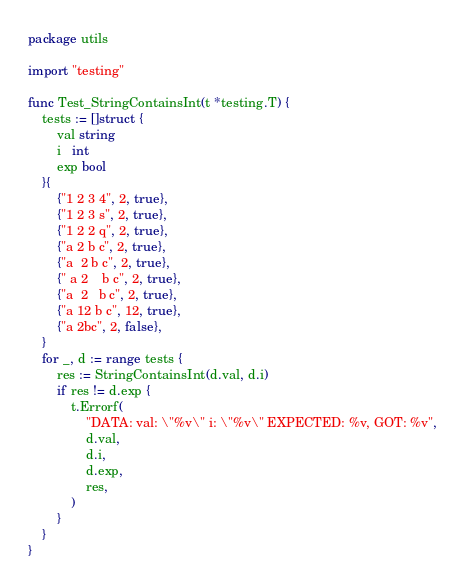Convert code to text. <code><loc_0><loc_0><loc_500><loc_500><_Go_>package utils

import "testing"

func Test_StringContainsInt(t *testing.T) {
	tests := []struct {
		val string
		i   int
		exp bool
	}{
		{"1 2 3 4", 2, true},
		{"1 2 3 s", 2, true},
		{"1 2 2 q", 2, true},
		{"a 2 b c", 2, true},
		{"a 	2 b c", 2, true},
		{" a 2 	 b c", 2, true},
		{"a	2	b c", 2, true},
		{"a 12 b c", 12, true},
		{"a 2bc", 2, false},
	}
	for _, d := range tests {
		res := StringContainsInt(d.val, d.i)
		if res != d.exp {
			t.Errorf(
				"DATA: val: \"%v\" i: \"%v\" EXPECTED: %v, GOT: %v",
				d.val,
				d.i,
				d.exp,
				res,
			)
		}
	}
}
</code> 